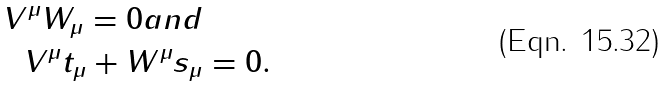Convert formula to latex. <formula><loc_0><loc_0><loc_500><loc_500>V ^ { \mu } W _ { \mu } = 0 a n d \\ V ^ { \mu } t _ { \mu } + W ^ { \mu } s _ { \mu } & = 0 .</formula> 